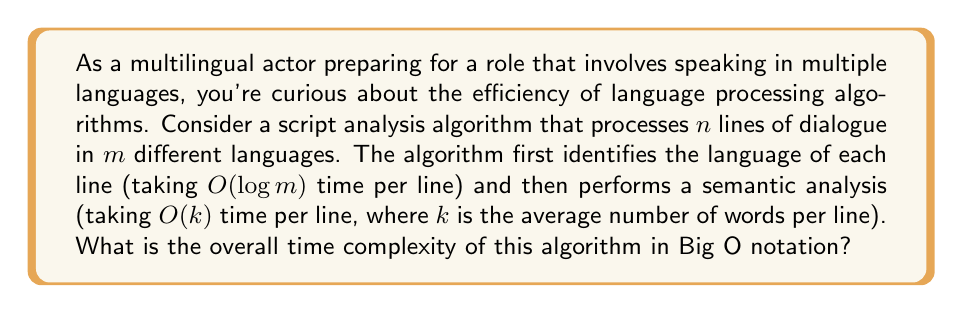Can you solve this math problem? Let's break down the problem and analyze it step by step:

1) Language Identification:
   - For each line, the algorithm takes $O(\log m)$ time to identify the language.
   - There are $n$ lines in total.
   - So, the total time for language identification is $O(n \log m)$.

2) Semantic Analysis:
   - For each line, the algorithm takes $O(k)$ time for semantic analysis.
   - There are $n$ lines in total.
   - So, the total time for semantic analysis is $O(nk)$.

3) Overall Time Complexity:
   - The algorithm performs both steps for each line.
   - Therefore, we add the complexities: $O(n \log m + nk)$

4) Simplification:
   - We can factor out $n$: $O(n(\log m + k))$
   - In Big O notation, we keep the term that grows the fastest.
   - Both $\log m$ and $k$ are independent of $n$, so we keep both.

Therefore, the overall time complexity remains $O(n(\log m + k))$.

This means that the running time of the algorithm grows linearly with the number of lines ($n$), and is also influenced by the number of languages ($m$) and the average number of words per line ($k$).
Answer: $O(n(\log m + k))$ 